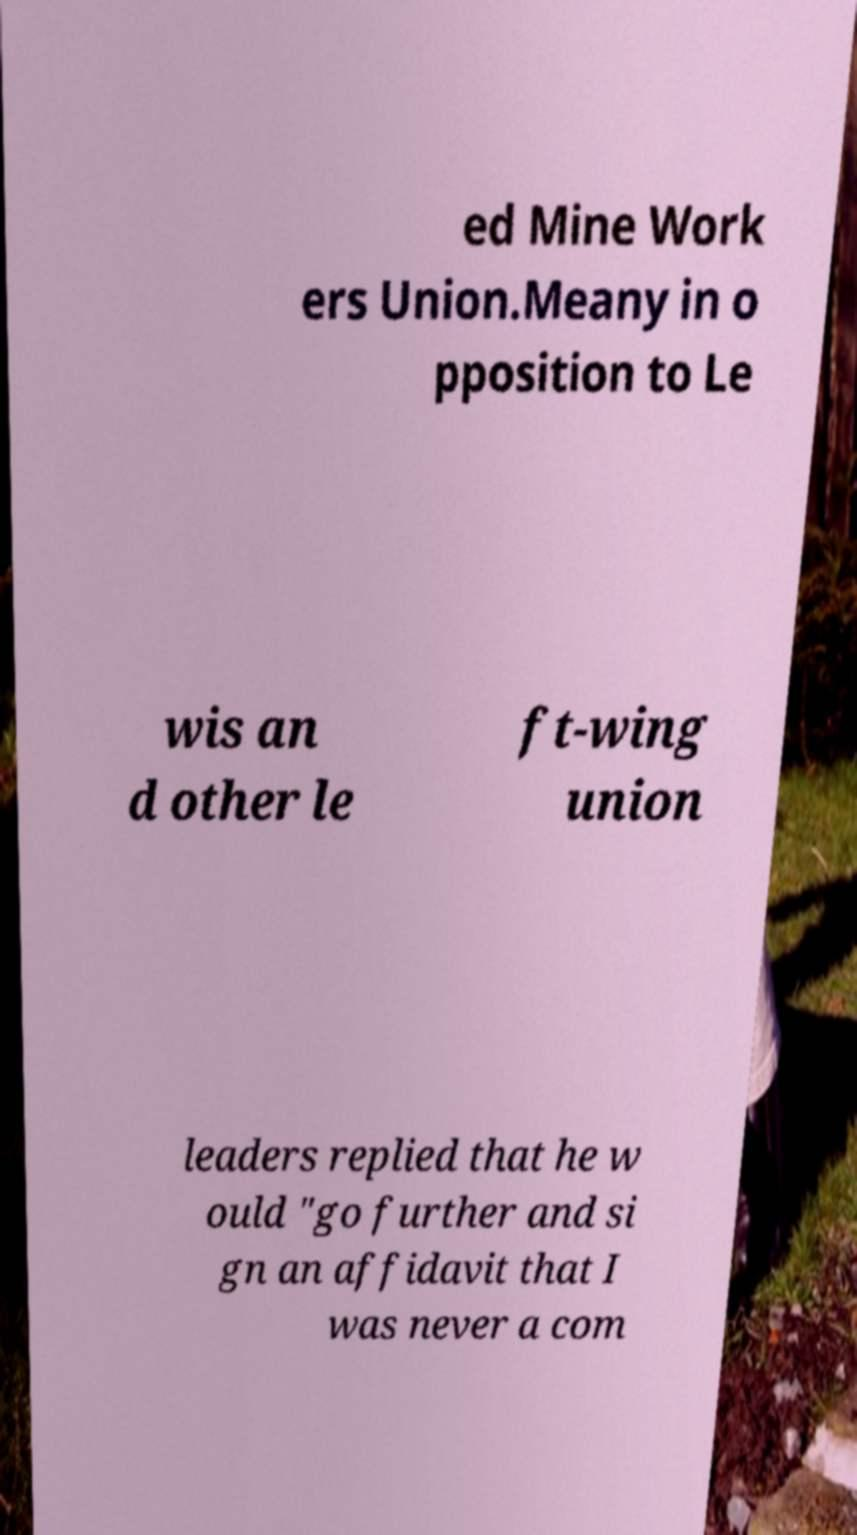Can you accurately transcribe the text from the provided image for me? ed Mine Work ers Union.Meany in o pposition to Le wis an d other le ft-wing union leaders replied that he w ould "go further and si gn an affidavit that I was never a com 